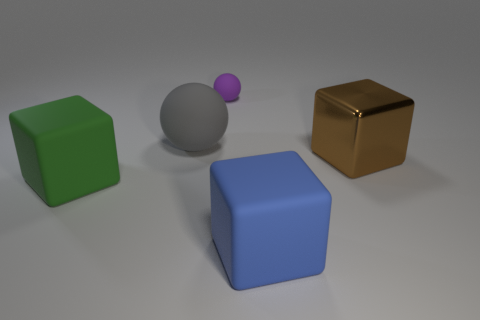Are the large blue block and the ball that is in front of the purple rubber ball made of the same material?
Give a very brief answer. Yes. What number of other objects are the same size as the purple sphere?
Ensure brevity in your answer.  0. Is there a gray matte ball that is to the right of the large matte block that is on the left side of the big rubber object behind the large brown block?
Provide a short and direct response. Yes. How big is the purple matte thing?
Offer a very short reply. Small. There is a cube that is on the left side of the purple object; what is its size?
Offer a terse response. Large. There is a cube that is behind the green cube; is it the same size as the gray sphere?
Make the answer very short. Yes. The tiny rubber thing has what shape?
Give a very brief answer. Sphere. How many blocks are both behind the big blue rubber block and to the right of the large gray rubber ball?
Keep it short and to the point. 1. What material is the green thing that is the same shape as the blue thing?
Keep it short and to the point. Rubber. Is there any other thing that is made of the same material as the large brown thing?
Ensure brevity in your answer.  No. 